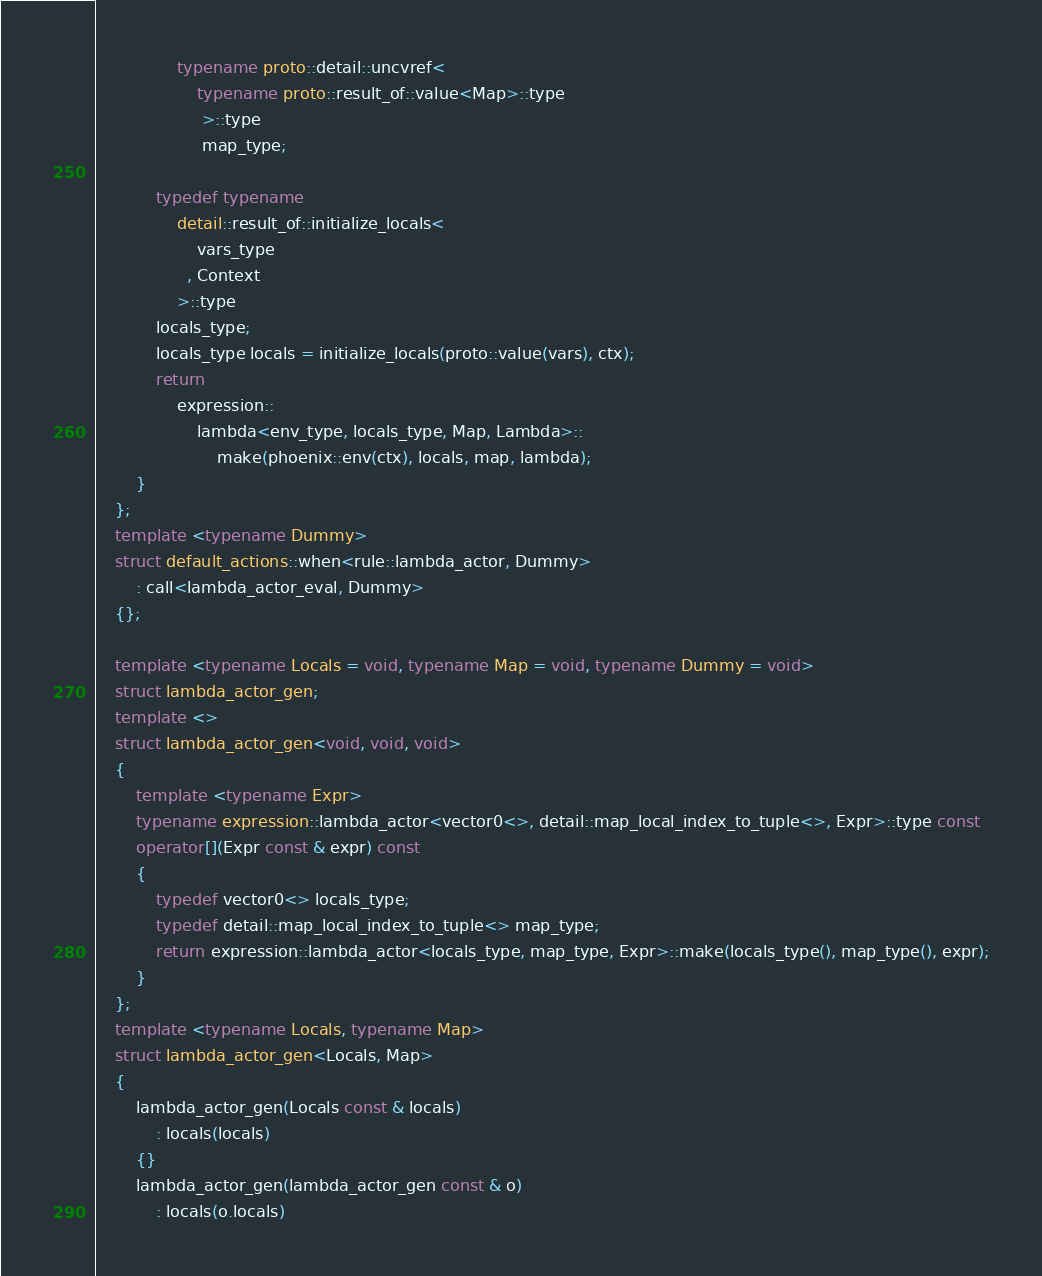Convert code to text. <code><loc_0><loc_0><loc_500><loc_500><_C++_>                typename proto::detail::uncvref<
                    typename proto::result_of::value<Map>::type
                     >::type
                     map_type;
            
            typedef typename 
                detail::result_of::initialize_locals<
                    vars_type
                  , Context
                >::type
            locals_type;
            locals_type locals = initialize_locals(proto::value(vars), ctx);
            return
                expression::
                    lambda<env_type, locals_type, Map, Lambda>::
                        make(phoenix::env(ctx), locals, map, lambda);
        }
    };
    template <typename Dummy>
    struct default_actions::when<rule::lambda_actor, Dummy>
        : call<lambda_actor_eval, Dummy>
    {};
    
    template <typename Locals = void, typename Map = void, typename Dummy = void>
    struct lambda_actor_gen;
    template <>
    struct lambda_actor_gen<void, void, void>
    {
        template <typename Expr>
        typename expression::lambda_actor<vector0<>, detail::map_local_index_to_tuple<>, Expr>::type const
        operator[](Expr const & expr) const
        {
            typedef vector0<> locals_type;
            typedef detail::map_local_index_to_tuple<> map_type;
            return expression::lambda_actor<locals_type, map_type, Expr>::make(locals_type(), map_type(), expr);
        }
    };
    template <typename Locals, typename Map>
    struct lambda_actor_gen<Locals, Map>
    {
        lambda_actor_gen(Locals const & locals)
            : locals(locals)
        {}
        lambda_actor_gen(lambda_actor_gen const & o)
            : locals(o.locals)</code> 